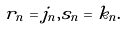<formula> <loc_0><loc_0><loc_500><loc_500>r _ { n } = j _ { n } , s _ { n } = k _ { n } .</formula> 